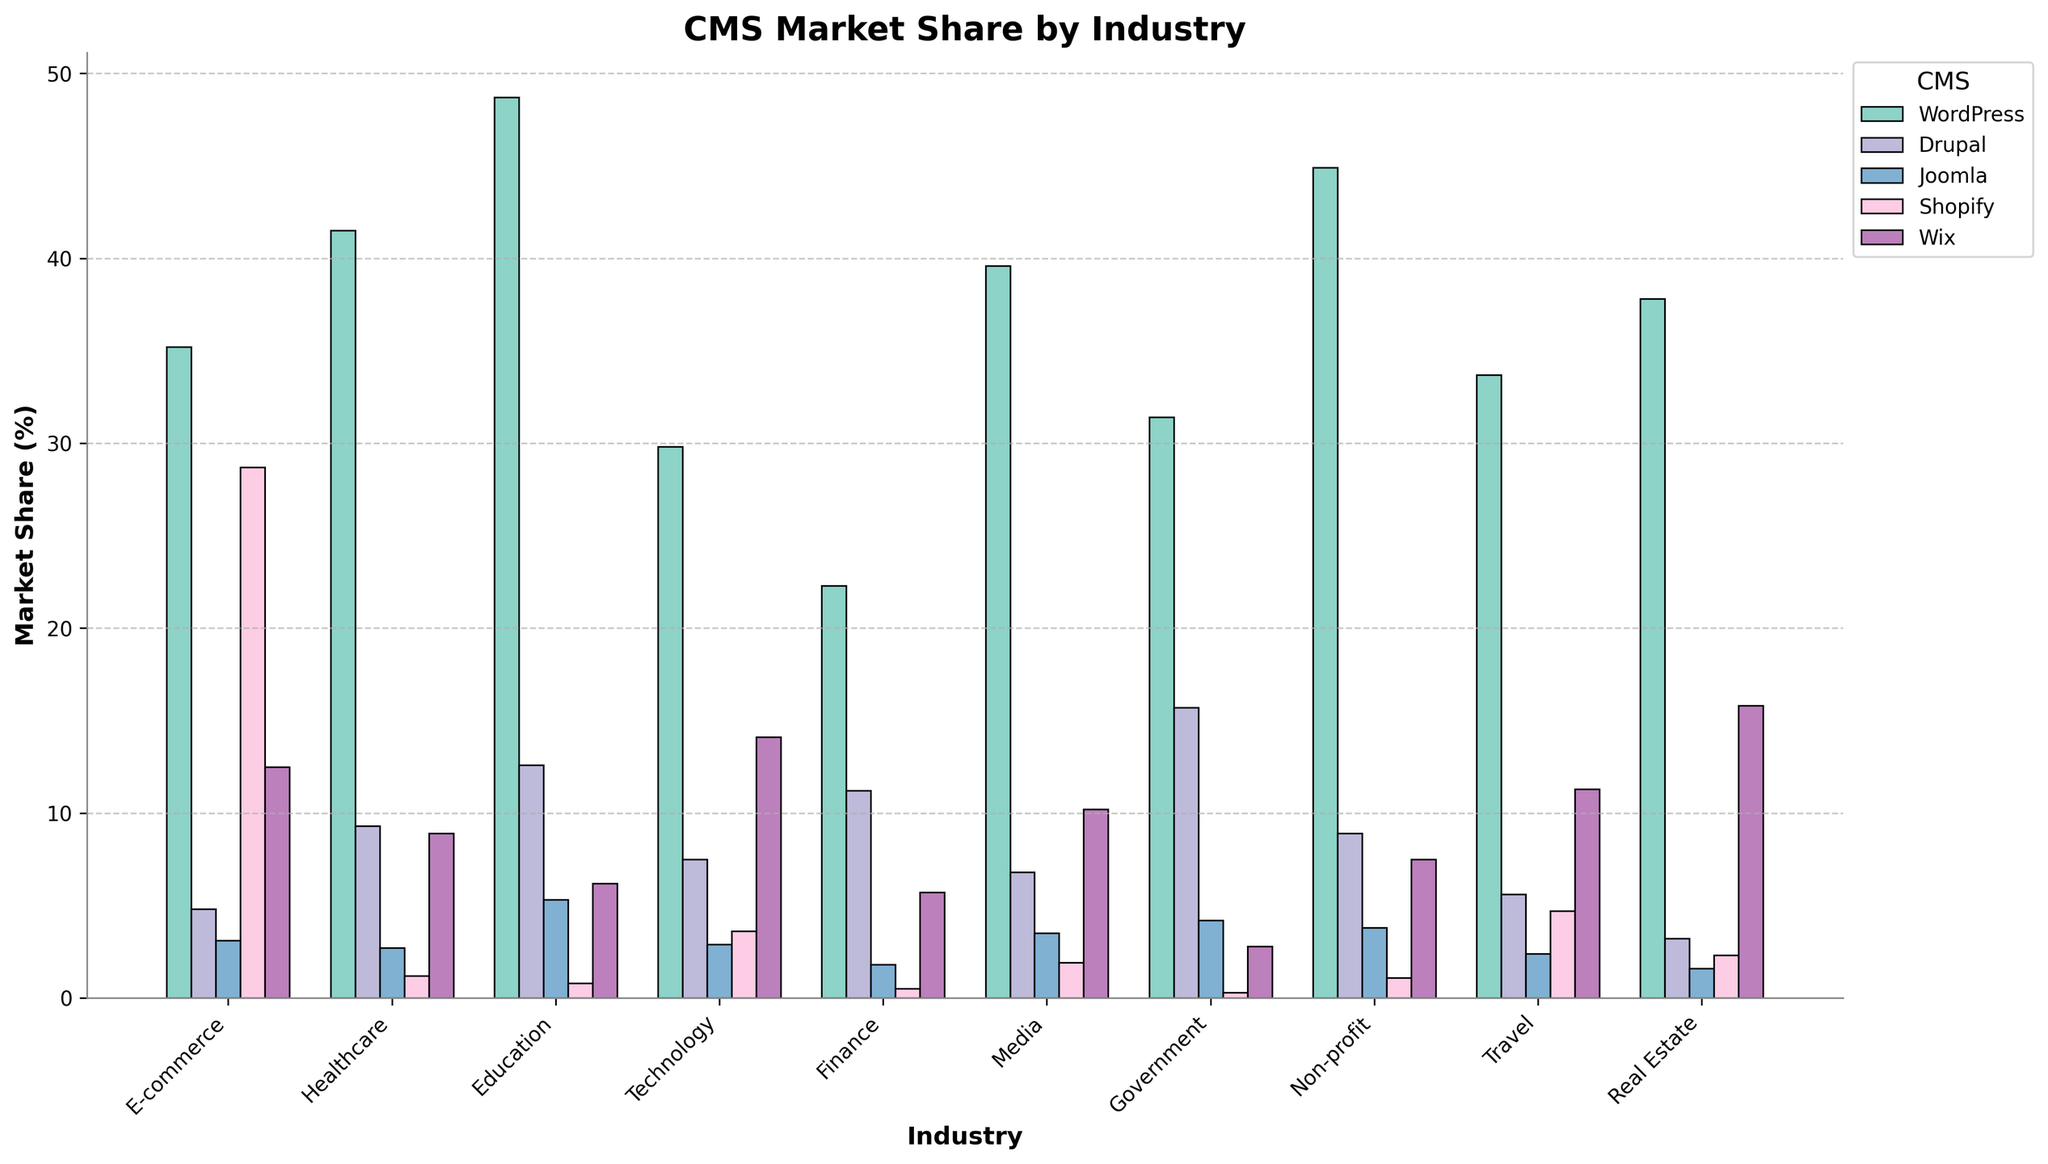What's the industry with the highest market share for WordPress? The highest bar for WordPress is in the Education industry, with a market share of 48.7%.
Answer: Education Which CMS has the lowest market share in the Technology industry? Among the CMSs displayed, Shopify has the lowest market share in the Technology industry at 3.6%.
Answer: Shopify Which industries have a higher market share for Drupal compared to Joomla? A higher Drupal market share compared to Joomla is seen in Education (12.6 > 5.3), Healthcare (9.3 > 2.7), Finance (11.2 > 1.8), Media (6.8 > 3.5), Government (15.7 > 4.2), Non-profit (8.9 > 3.8), and Travel (5.6 > 2.4).
Answer: Education, Healthcare, Finance, Media, Government, Non-profit, Travel What is the sum of the market shares for Shopify in the E-commerce and Real Estate industries? Shopify's market share in E-commerce is 28.7% and in Real Estate is 2.3%. Summing them up gives 28.7 + 2.3 = 31.0.
Answer: 31.0 Which CMS has the most consistent market share across all industries? To determine consistency, observe the fluctuations in market share across all industries. WordPress shows relatively high market share with less fluctuation across industries compared to others.
Answer: WordPress In which industry does the sum of market shares for Joomla and Wix exceed 15%? Checking each industry: E-commerce (3.1 + 12.5 = 15.6), Healthcare (2.7 + 8.9 = 11.6), Education (5.3 + 6.2 = 11.5), Technology (2.9 + 14.1 = 17.0), etc. The industries are E-commerce and Technology.
Answer: E-commerce, Technology 